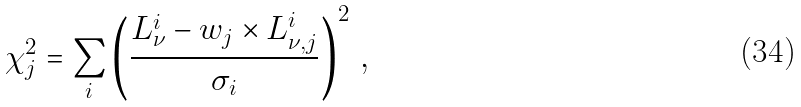Convert formula to latex. <formula><loc_0><loc_0><loc_500><loc_500>\chi _ { j } ^ { 2 } = \sum _ { i } \left ( \frac { L _ { \nu } ^ { i } - w _ { j } \times L _ { \nu , j } ^ { i } } { \sigma _ { i } } \right ) ^ { 2 } \, ,</formula> 